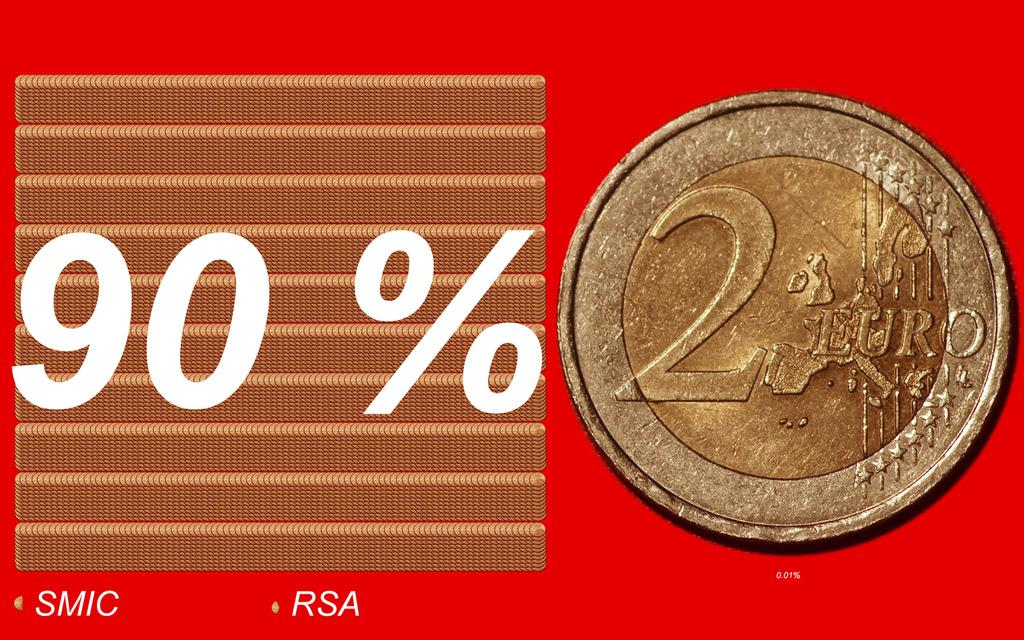Provide a one-sentence caption for the provided image. An ad for a coin that shows the number 2 on it and says 90% on the ad. 